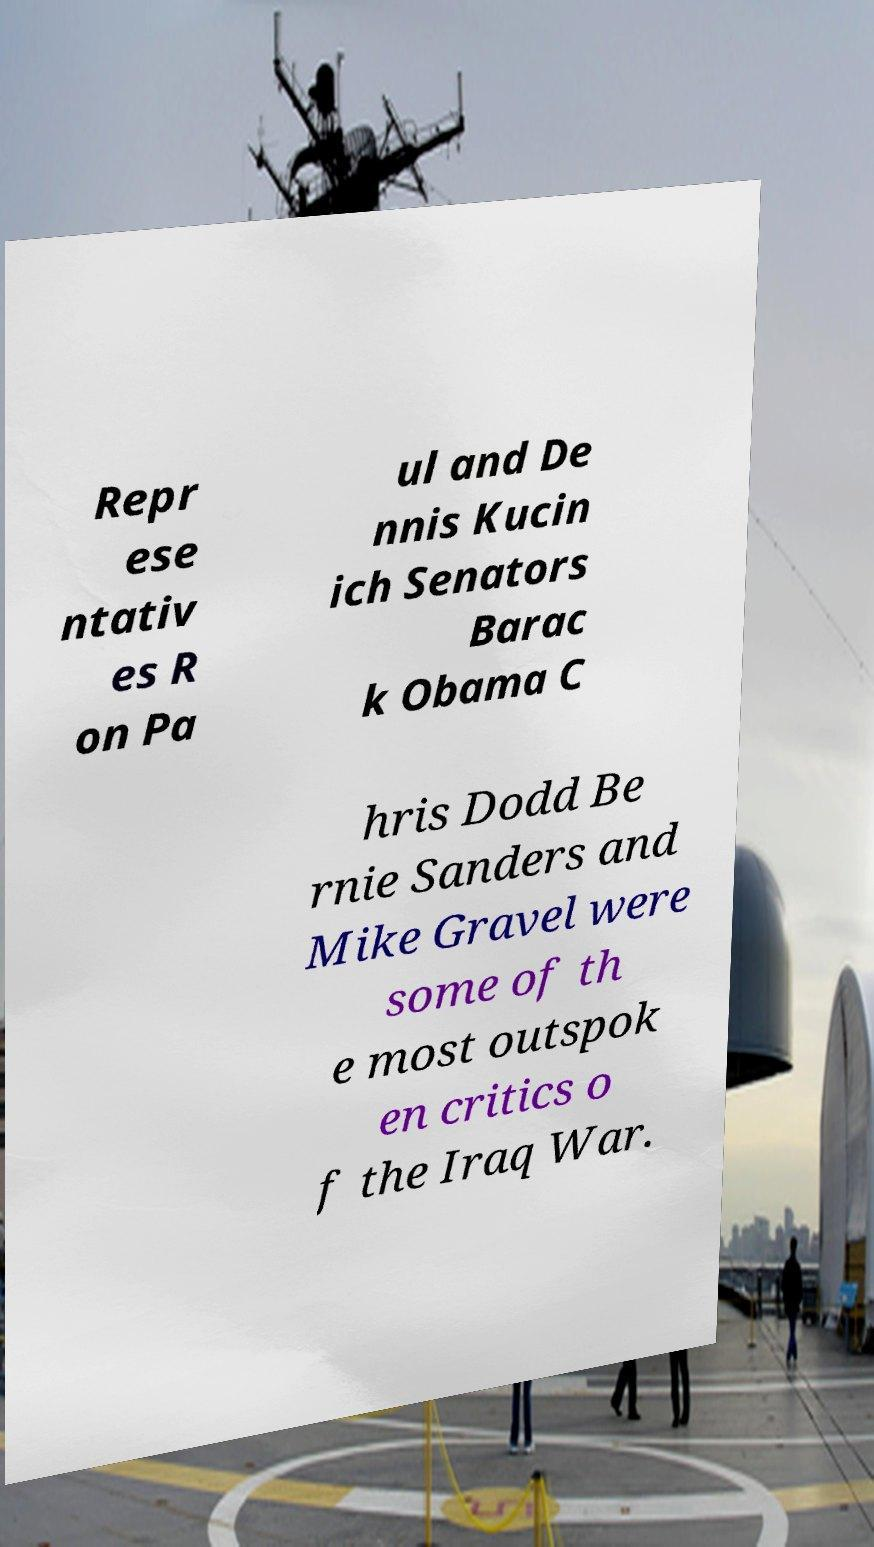Please identify and transcribe the text found in this image. Repr ese ntativ es R on Pa ul and De nnis Kucin ich Senators Barac k Obama C hris Dodd Be rnie Sanders and Mike Gravel were some of th e most outspok en critics o f the Iraq War. 